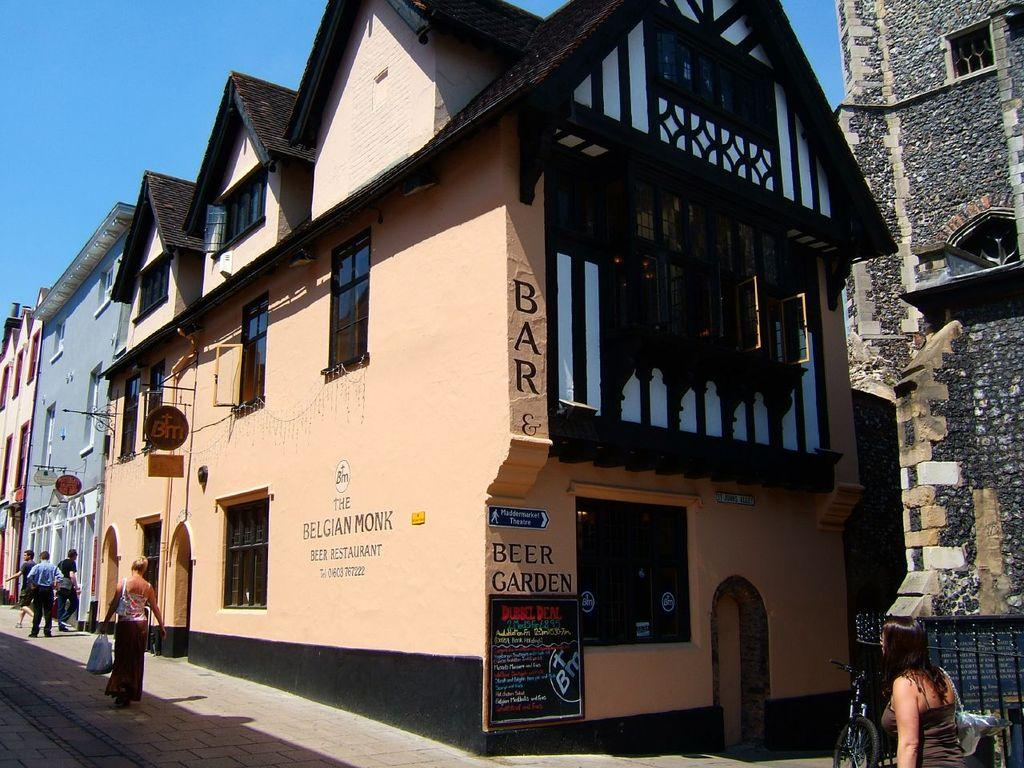What type of structures are visible in the image? There are buildings in the image. What can be seen at the top of the image? The sky is visible at the top of the image. Are there any people in the image? Yes, there are persons in front of the buildings. What mode of transportation can be seen in front of the building at the bottom of the image? A bicycle is present in front of the building at the bottom of the image. Where is the goat located in the image? There is no goat present in the image. What color is the orange in the image? There is no orange present in the image. 